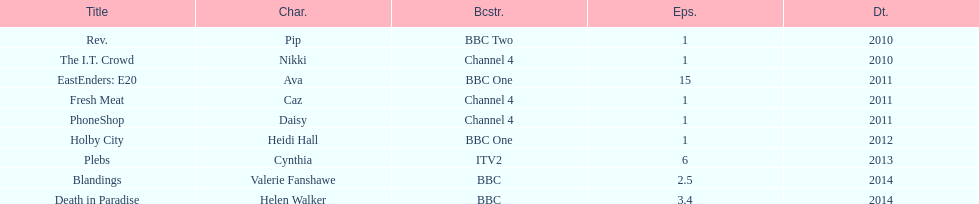What is the only role she played with broadcaster itv2? Cynthia. 